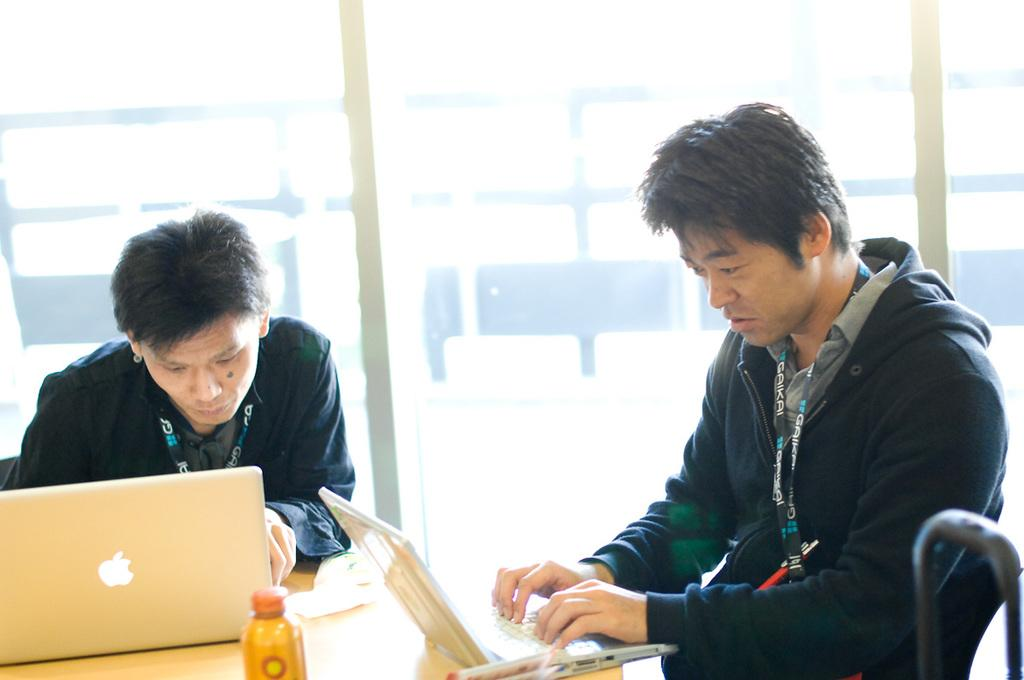How many people are in the image? There are two men in the image. What are the men doing in the image? The men are working with laptops. Where are the laptops located in relation to the men? The laptops are in front of the men. What surface are the laptops placed on? The laptops are on a table. What other objects can be seen on the table? There is a bottle and a book on the table. Can you tell me what type of pen the men are using to write on the zoo map in the image? There is no pen or zoo map present in the image; the men are working with laptops. What advice would the men's aunt give them about their work in the image? There is no mention of an aunt in the image, so it is impossible to determine what advice she might give. 